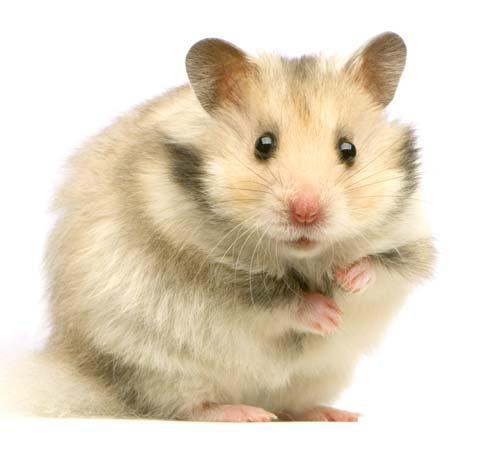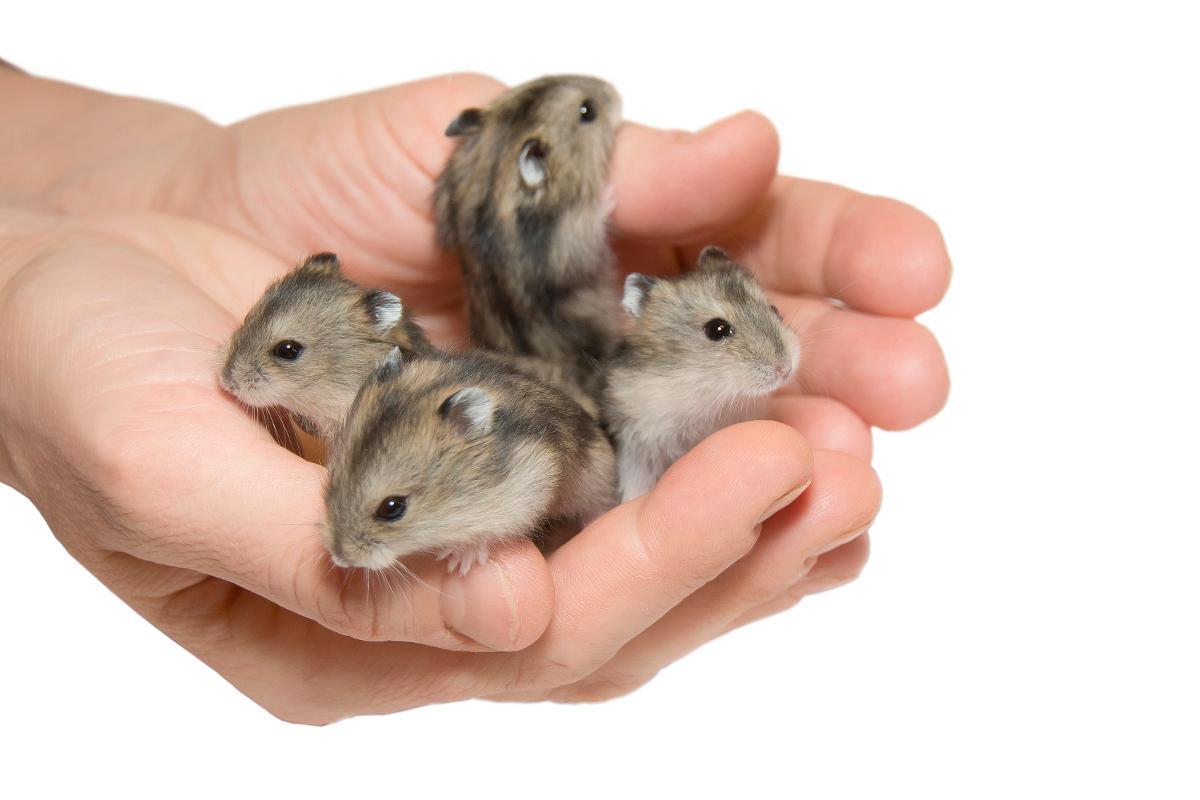The first image is the image on the left, the second image is the image on the right. Assess this claim about the two images: "A hand is holding multiple hamsters with mottled grayish-brown fir.". Correct or not? Answer yes or no. Yes. 